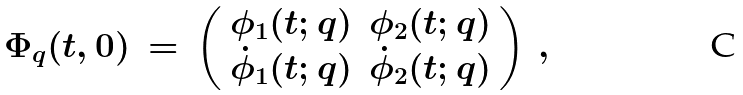<formula> <loc_0><loc_0><loc_500><loc_500>\Phi _ { q } ( t , 0 ) \, = \, \left ( \begin{array} { c c } \phi _ { 1 } ( t ; q ) & \phi _ { 2 } ( t ; q ) \\ { \dot { \phi } _ { 1 } ( t ; q ) } & { \dot { \phi } _ { 2 } ( t ; q ) } \end{array} \right ) \, ,</formula> 